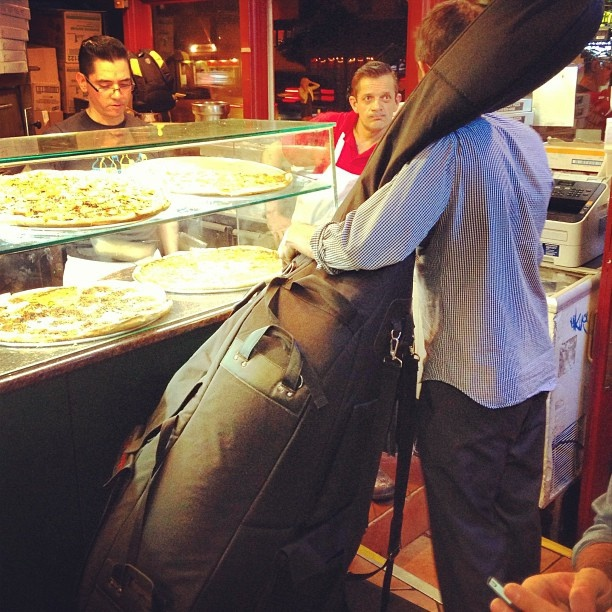Describe the objects in this image and their specific colors. I can see people in brown, black, darkgray, and gray tones, suitcase in brown, black, and maroon tones, people in brown, tan, beige, khaki, and red tones, pizza in brown, beige, khaki, and tan tones, and pizza in brown, lightyellow, khaki, and tan tones in this image. 